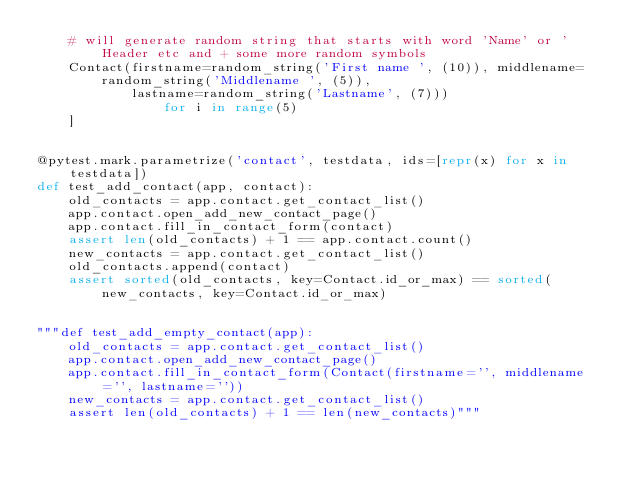Convert code to text. <code><loc_0><loc_0><loc_500><loc_500><_Python_>    # will generate random string that starts with word 'Name' or 'Header etc and + some more random symbols
    Contact(firstname=random_string('First name ', (10)), middlename=random_string('Middlename ', (5)),
            lastname=random_string('Lastname', (7)))
                for i in range(5)
    ]


@pytest.mark.parametrize('contact', testdata, ids=[repr(x) for x in testdata])
def test_add_contact(app, contact):
    old_contacts = app.contact.get_contact_list()
    app.contact.open_add_new_contact_page()
    app.contact.fill_in_contact_form(contact)
    assert len(old_contacts) + 1 == app.contact.count()
    new_contacts = app.contact.get_contact_list()
    old_contacts.append(contact)
    assert sorted(old_contacts, key=Contact.id_or_max) == sorted(new_contacts, key=Contact.id_or_max)


"""def test_add_empty_contact(app):
    old_contacts = app.contact.get_contact_list()
    app.contact.open_add_new_contact_page()
    app.contact.fill_in_contact_form(Contact(firstname='', middlename='', lastname=''))
    new_contacts = app.contact.get_contact_list()
    assert len(old_contacts) + 1 == len(new_contacts)"""
</code> 